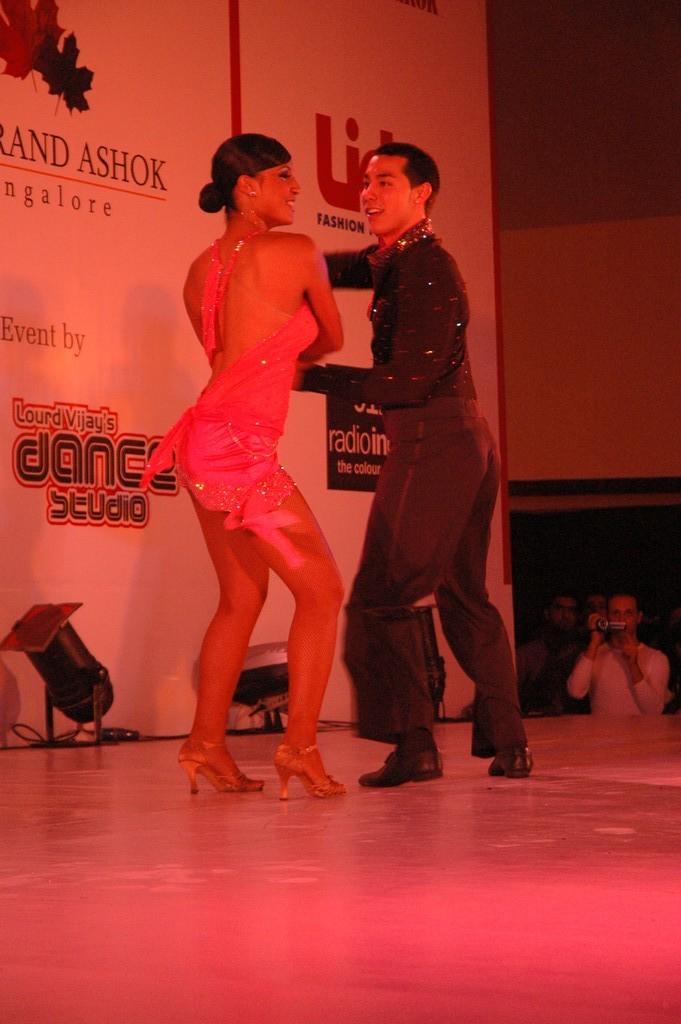How many people are in the image? There are two persons in the image. What are the two persons doing in the image? The two persons are dancing. Can you describe the clothing of the person on the right? The person on the right is wearing a black dress. What can be seen in the background of the image? There is a board visible in the background of the image. What type of yam is being used as a prop in the dance? There is no yam present in the image, and therefore it cannot be used as a prop in the dance. 